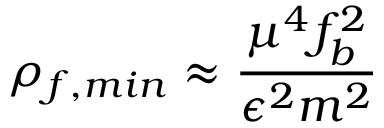<formula> <loc_0><loc_0><loc_500><loc_500>\rho _ { f , \min } \approx { \frac { \mu ^ { 4 } f _ { b } ^ { 2 } } { \epsilon ^ { 2 } m ^ { 2 } } }</formula> 